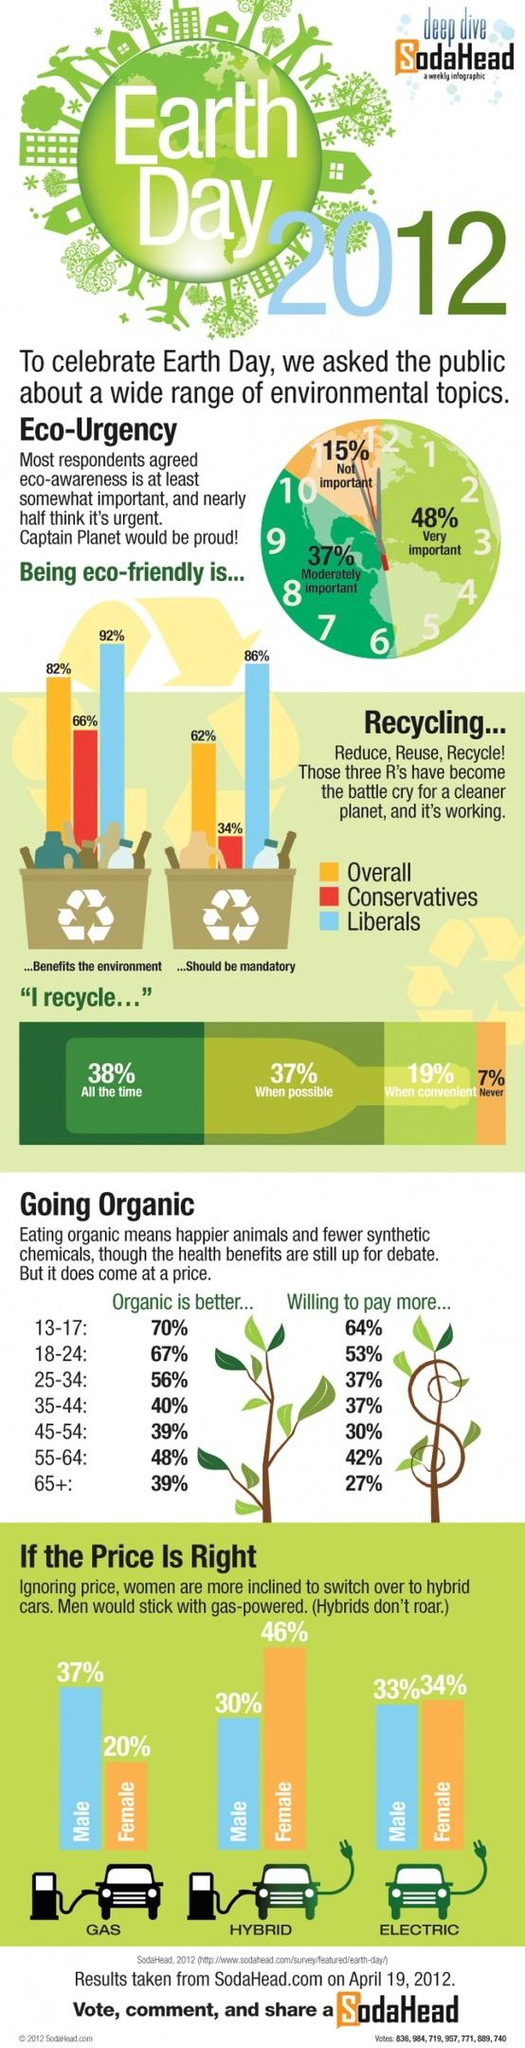Indicate a few pertinent items in this graphic. In the survey, 62% of the respondents believe that recycling should be mandatory. According to the given text, it is revealed that the age group of 13-17 is willing to pay more for organic food. According to recent data, only 1% of women have switched to electric cars. The image of a globe depicts the text 'Earth Day.' According to the survey, 48% of respondents believe that environment awareness needs to be developed immediately. 